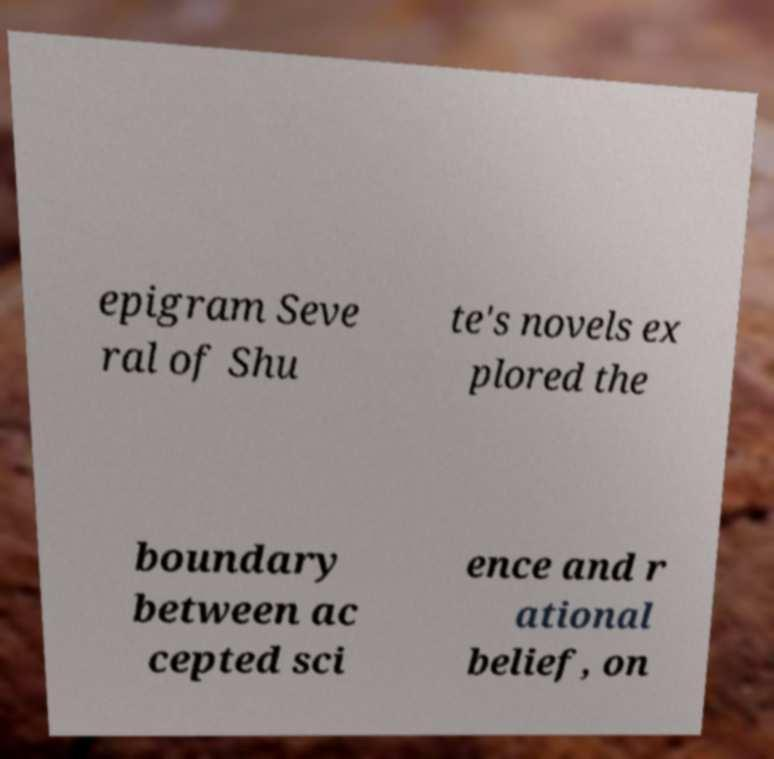Could you assist in decoding the text presented in this image and type it out clearly? epigram Seve ral of Shu te's novels ex plored the boundary between ac cepted sci ence and r ational belief, on 